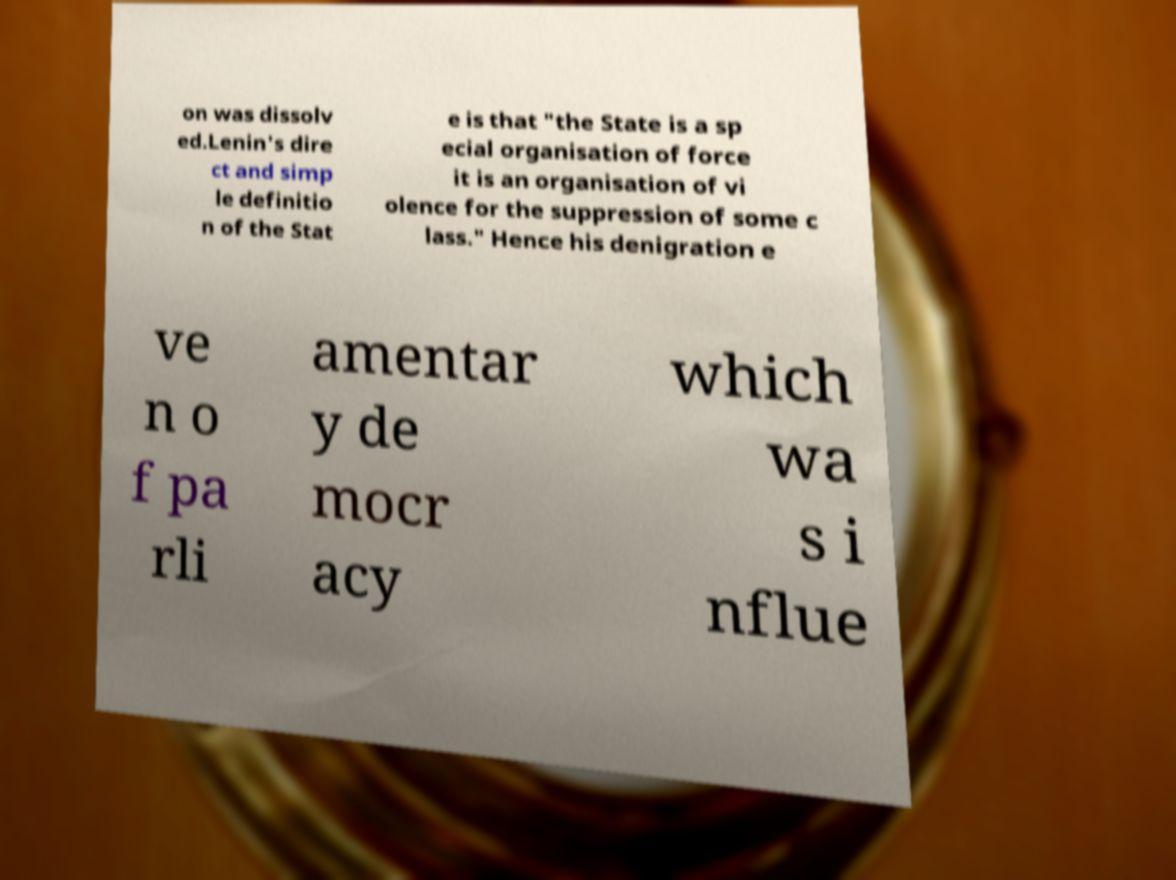For documentation purposes, I need the text within this image transcribed. Could you provide that? on was dissolv ed.Lenin's dire ct and simp le definitio n of the Stat e is that "the State is a sp ecial organisation of force it is an organisation of vi olence for the suppression of some c lass." Hence his denigration e ve n o f pa rli amentar y de mocr acy which wa s i nflue 